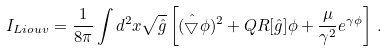Convert formula to latex. <formula><loc_0><loc_0><loc_500><loc_500>I _ { L i o u v } = \frac { 1 } { 8 \pi } \int d ^ { 2 } x \sqrt { \hat { g } } \left [ ( \hat { \bigtriangledown } \phi ) ^ { 2 } + Q R [ \hat { g } ] \phi + \frac { \mu } { \gamma ^ { 2 } } e ^ { \gamma \phi } \right ] \, .</formula> 